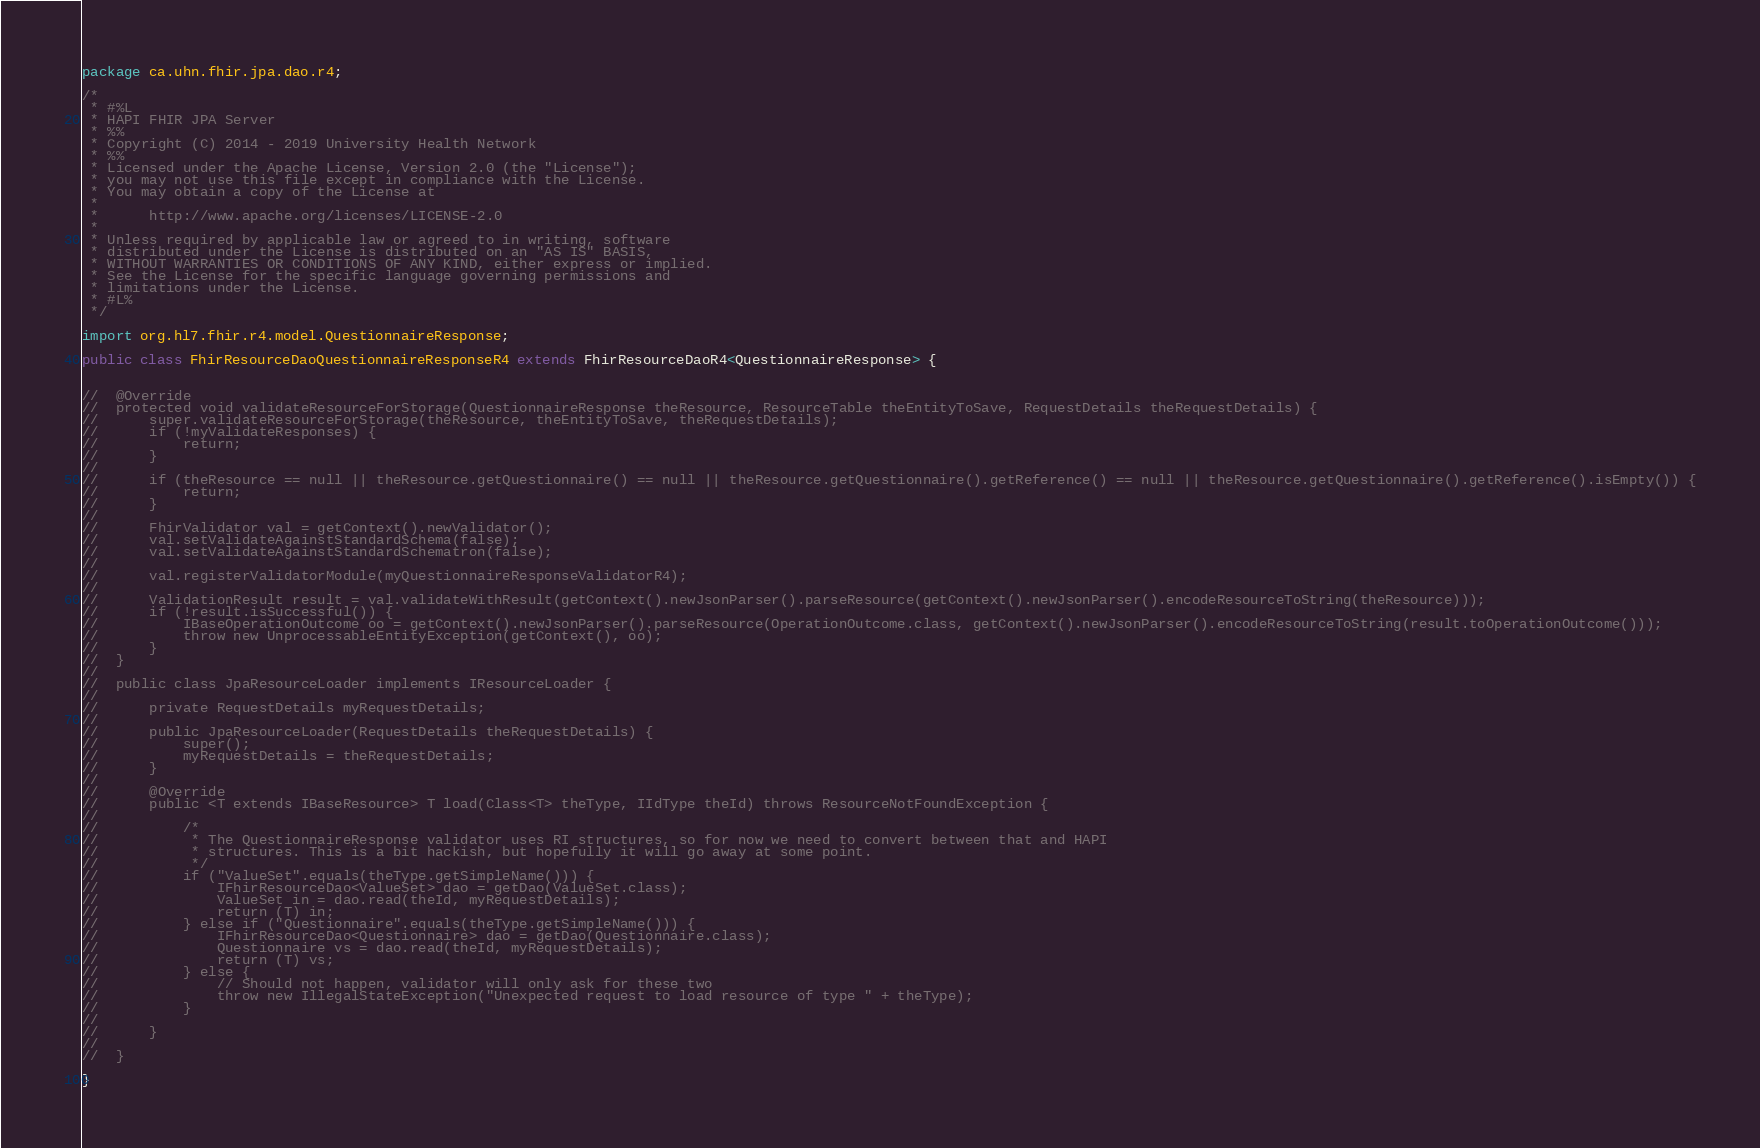Convert code to text. <code><loc_0><loc_0><loc_500><loc_500><_Java_>package ca.uhn.fhir.jpa.dao.r4;

/*
 * #%L
 * HAPI FHIR JPA Server
 * %%
 * Copyright (C) 2014 - 2019 University Health Network
 * %%
 * Licensed under the Apache License, Version 2.0 (the "License");
 * you may not use this file except in compliance with the License.
 * You may obtain a copy of the License at
 * 
 *      http://www.apache.org/licenses/LICENSE-2.0
 * 
 * Unless required by applicable law or agreed to in writing, software
 * distributed under the License is distributed on an "AS IS" BASIS,
 * WITHOUT WARRANTIES OR CONDITIONS OF ANY KIND, either express or implied.
 * See the License for the specific language governing permissions and
 * limitations under the License.
 * #L%
 */

import org.hl7.fhir.r4.model.QuestionnaireResponse;

public class FhirResourceDaoQuestionnaireResponseR4 extends FhirResourceDaoR4<QuestionnaireResponse> {

	
//	@Override
//	protected void validateResourceForStorage(QuestionnaireResponse theResource, ResourceTable theEntityToSave, RequestDetails theRequestDetails) {
//		super.validateResourceForStorage(theResource, theEntityToSave, theRequestDetails);
//		if (!myValidateResponses) {
//			return;
//		}
//		
//		if (theResource == null || theResource.getQuestionnaire() == null || theResource.getQuestionnaire().getReference() == null || theResource.getQuestionnaire().getReference().isEmpty()) {
//			return;
//		}
//
//		FhirValidator val = getContext().newValidator();
//		val.setValidateAgainstStandardSchema(false);
//		val.setValidateAgainstStandardSchematron(false);
//
//		val.registerValidatorModule(myQuestionnaireResponseValidatorR4);
//
//		ValidationResult result = val.validateWithResult(getContext().newJsonParser().parseResource(getContext().newJsonParser().encodeResourceToString(theResource)));
//		if (!result.isSuccessful()) {
//			IBaseOperationOutcome oo = getContext().newJsonParser().parseResource(OperationOutcome.class, getContext().newJsonParser().encodeResourceToString(result.toOperationOutcome()));
//			throw new UnprocessableEntityException(getContext(), oo);
//		}
//	}
//
//	public class JpaResourceLoader implements IResourceLoader {
//
//		private RequestDetails myRequestDetails;
//
//		public JpaResourceLoader(RequestDetails theRequestDetails) {
//			super();
//			myRequestDetails = theRequestDetails;
//		}
//
//		@Override
//		public <T extends IBaseResource> T load(Class<T> theType, IIdType theId) throws ResourceNotFoundException {
//
//			/*
//			 * The QuestionnaireResponse validator uses RI structures, so for now we need to convert between that and HAPI
//			 * structures. This is a bit hackish, but hopefully it will go away at some point.
//			 */
//			if ("ValueSet".equals(theType.getSimpleName())) {
//				IFhirResourceDao<ValueSet> dao = getDao(ValueSet.class);
//				ValueSet in = dao.read(theId, myRequestDetails);
//				return (T) in;
//			} else if ("Questionnaire".equals(theType.getSimpleName())) {
//				IFhirResourceDao<Questionnaire> dao = getDao(Questionnaire.class);
//				Questionnaire vs = dao.read(theId, myRequestDetails);
//				return (T) vs;
//			} else {
//				// Should not happen, validator will only ask for these two
//				throw new IllegalStateException("Unexpected request to load resource of type " + theType);
//			}
//
//		}
//
//	}

}
</code> 